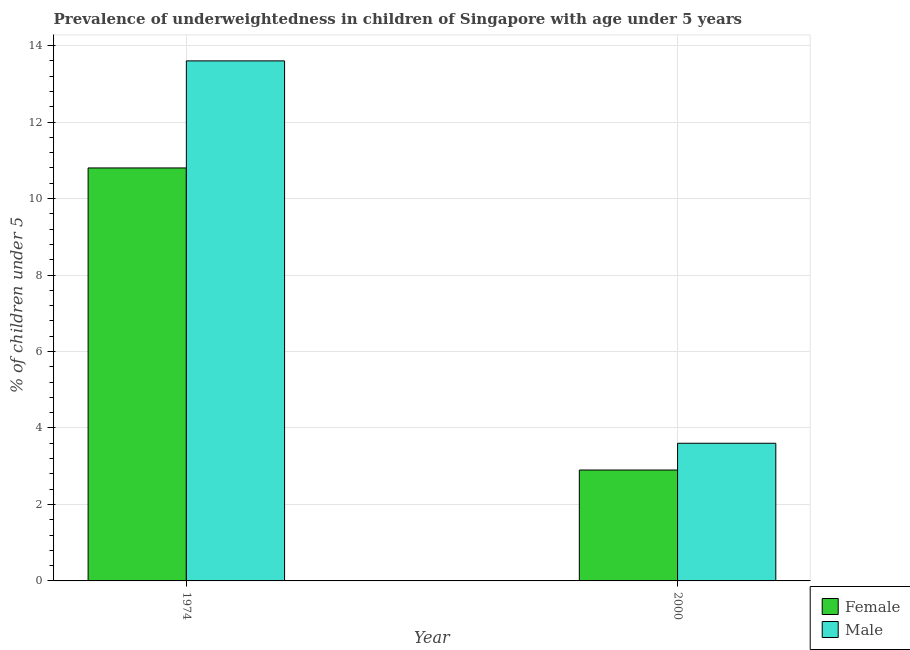Are the number of bars on each tick of the X-axis equal?
Offer a terse response. Yes. What is the label of the 1st group of bars from the left?
Ensure brevity in your answer.  1974. What is the percentage of underweighted male children in 1974?
Ensure brevity in your answer.  13.6. Across all years, what is the maximum percentage of underweighted male children?
Keep it short and to the point. 13.6. Across all years, what is the minimum percentage of underweighted male children?
Keep it short and to the point. 3.6. In which year was the percentage of underweighted female children maximum?
Your answer should be very brief. 1974. In which year was the percentage of underweighted male children minimum?
Offer a very short reply. 2000. What is the total percentage of underweighted male children in the graph?
Provide a short and direct response. 17.2. What is the difference between the percentage of underweighted male children in 1974 and that in 2000?
Provide a succinct answer. 10. What is the difference between the percentage of underweighted female children in 1974 and the percentage of underweighted male children in 2000?
Ensure brevity in your answer.  7.9. What is the average percentage of underweighted male children per year?
Your answer should be compact. 8.6. In the year 2000, what is the difference between the percentage of underweighted female children and percentage of underweighted male children?
Your answer should be very brief. 0. In how many years, is the percentage of underweighted male children greater than 1.2000000000000002 %?
Your response must be concise. 2. What is the ratio of the percentage of underweighted female children in 1974 to that in 2000?
Provide a succinct answer. 3.72. What does the 1st bar from the right in 1974 represents?
Ensure brevity in your answer.  Male. How many years are there in the graph?
Give a very brief answer. 2. What is the difference between two consecutive major ticks on the Y-axis?
Ensure brevity in your answer.  2. Are the values on the major ticks of Y-axis written in scientific E-notation?
Keep it short and to the point. No. Does the graph contain any zero values?
Give a very brief answer. No. Does the graph contain grids?
Your answer should be compact. Yes. What is the title of the graph?
Your answer should be very brief. Prevalence of underweightedness in children of Singapore with age under 5 years. Does "Register a property" appear as one of the legend labels in the graph?
Provide a short and direct response. No. What is the label or title of the X-axis?
Provide a short and direct response. Year. What is the label or title of the Y-axis?
Your response must be concise.  % of children under 5. What is the  % of children under 5 in Female in 1974?
Keep it short and to the point. 10.8. What is the  % of children under 5 of Male in 1974?
Offer a terse response. 13.6. What is the  % of children under 5 of Female in 2000?
Make the answer very short. 2.9. What is the  % of children under 5 in Male in 2000?
Keep it short and to the point. 3.6. Across all years, what is the maximum  % of children under 5 of Female?
Make the answer very short. 10.8. Across all years, what is the maximum  % of children under 5 of Male?
Your answer should be very brief. 13.6. Across all years, what is the minimum  % of children under 5 of Female?
Your answer should be compact. 2.9. Across all years, what is the minimum  % of children under 5 in Male?
Your answer should be very brief. 3.6. What is the total  % of children under 5 in Female in the graph?
Your answer should be compact. 13.7. What is the total  % of children under 5 in Male in the graph?
Your answer should be very brief. 17.2. What is the difference between the  % of children under 5 in Female in 1974 and that in 2000?
Your answer should be very brief. 7.9. What is the average  % of children under 5 in Female per year?
Provide a short and direct response. 6.85. What is the ratio of the  % of children under 5 of Female in 1974 to that in 2000?
Give a very brief answer. 3.72. What is the ratio of the  % of children under 5 of Male in 1974 to that in 2000?
Offer a terse response. 3.78. 